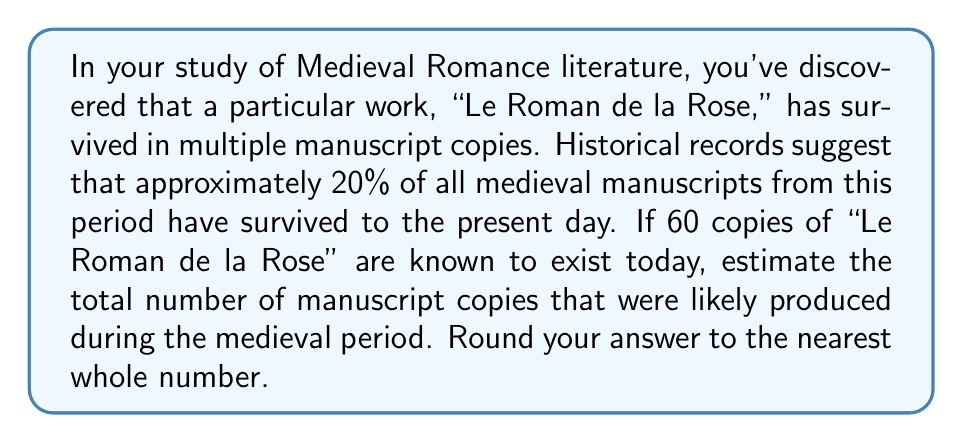Solve this math problem. To solve this problem, we need to use probability and the given information to estimate the original number of manuscripts. Let's approach this step-by-step:

1) Let $x$ be the original number of manuscripts produced.

2) We know that 20% of all manuscripts from this period have survived. This can be expressed as a probability:

   $P(\text{survival}) = 0.20$

3) We also know that 60 copies have survived to the present day. This can be expressed as:

   $0.20x = 60$

4) To find $x$, we solve this equation:

   $x = \frac{60}{0.20} = \frac{60}{1/5} = 60 \cdot 5 = 300$

5) Therefore, if 20% of the manuscripts survived and we have 60 copies today, we can estimate that approximately 300 copies were originally produced.

This problem utilizes the concept of inverse probability, where we use the known outcome (60 surviving copies) and the probability of that outcome (20% survival rate) to estimate the original population size.
Answer: 300 manuscripts 